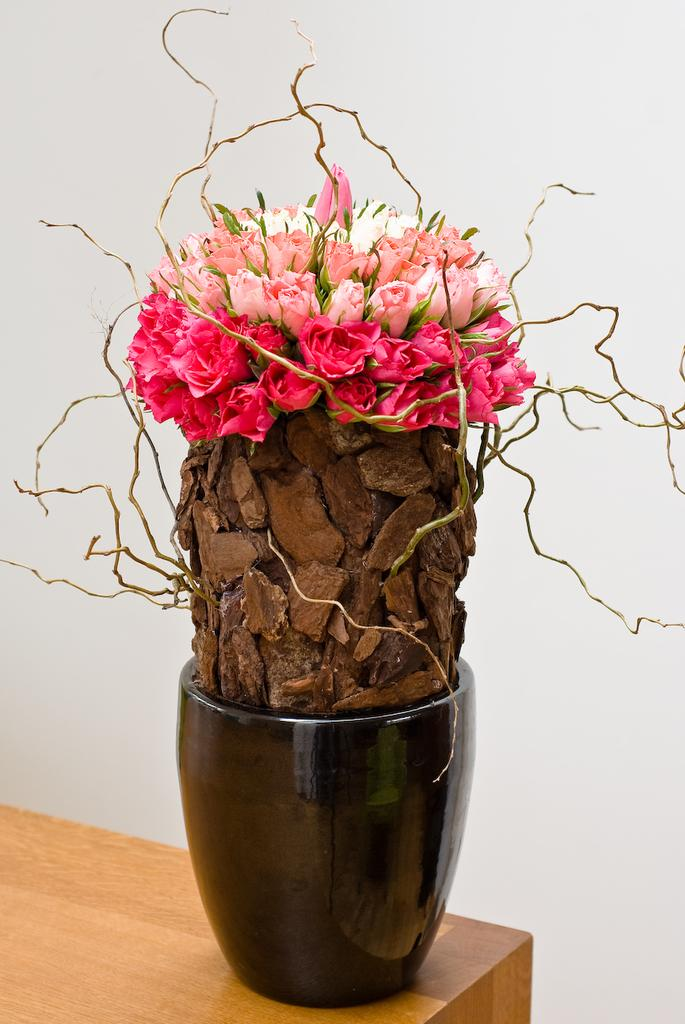What piece of furniture is present in the image? There is a table in the image. What is placed on the table? There is a flower vase on the table. What is located beside the table? There is a wall beside the table. What type of jeans is the person wearing in the image? There is no person or jeans present in the image; it only features a table, a flower vase, and a wall. 